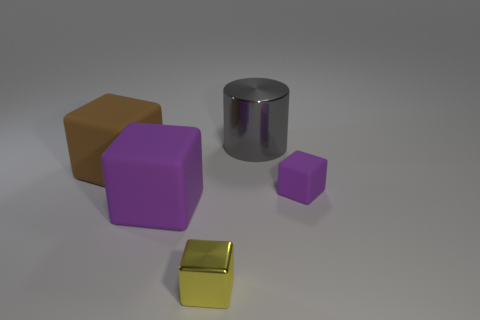Add 2 large yellow rubber cylinders. How many objects exist? 7 Subtract all brown cubes. How many cubes are left? 3 Subtract 4 cubes. How many cubes are left? 0 Subtract all cubes. How many objects are left? 1 Subtract all brown spheres. How many brown cubes are left? 1 Subtract all small cyan rubber cylinders. Subtract all small cubes. How many objects are left? 3 Add 4 metal things. How many metal things are left? 6 Add 1 big red cylinders. How many big red cylinders exist? 1 Subtract all purple cubes. How many cubes are left? 2 Subtract 0 gray balls. How many objects are left? 5 